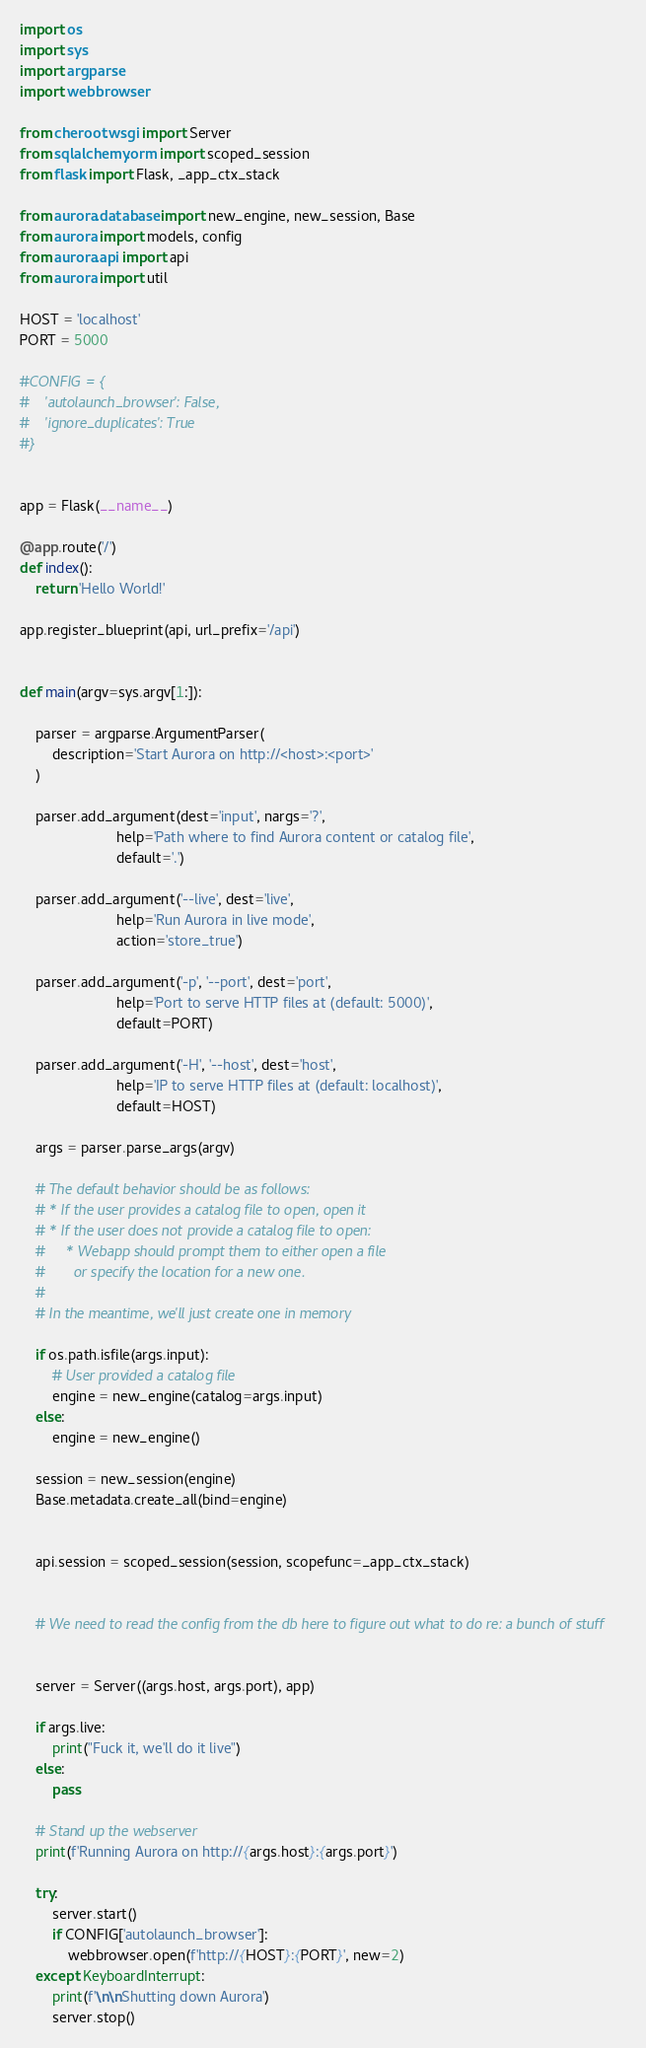Convert code to text. <code><loc_0><loc_0><loc_500><loc_500><_Python_>import os
import sys
import argparse
import webbrowser

from cheroot.wsgi import Server
from sqlalchemy.orm import scoped_session
from flask import Flask, _app_ctx_stack

from aurora.database import new_engine, new_session, Base
from aurora import models, config
from aurora.api import api
from aurora import util

HOST = 'localhost'
PORT = 5000

#CONFIG = {
#    'autolaunch_browser': False,
#    'ignore_duplicates': True
#}


app = Flask(__name__)

@app.route('/')
def index():
    return 'Hello World!'

app.register_blueprint(api, url_prefix='/api')


def main(argv=sys.argv[1:]):

    parser = argparse.ArgumentParser(
        description='Start Aurora on http://<host>:<port>'
    )
    
    parser.add_argument(dest='input', nargs='?',
                        help='Path where to find Aurora content or catalog file',
                        default='.')

    parser.add_argument('--live', dest='live',
                        help='Run Aurora in live mode',
                        action='store_true')

    parser.add_argument('-p', '--port', dest='port',
                        help='Port to serve HTTP files at (default: 5000)',
                        default=PORT)

    parser.add_argument('-H', '--host', dest='host',
                        help='IP to serve HTTP files at (default: localhost)',
                        default=HOST)
    
    args = parser.parse_args(argv)

    # The default behavior should be as follows:
    # * If the user provides a catalog file to open, open it
    # * If the user does not provide a catalog file to open:
    #     * Webapp should prompt them to either open a file
    #       or specify the location for a new one.
    #
    # In the meantime, we'll just create one in memory

    if os.path.isfile(args.input):
        # User provided a catalog file
        engine = new_engine(catalog=args.input)
    else:
        engine = new_engine()

    session = new_session(engine)
    Base.metadata.create_all(bind=engine)


    api.session = scoped_session(session, scopefunc=_app_ctx_stack)


    # We need to read the config from the db here to figure out what to do re: a bunch of stuff


    server = Server((args.host, args.port), app)

    if args.live:
        print("Fuck it, we'll do it live")
    else:
        pass

    # Stand up the webserver
    print(f'Running Aurora on http://{args.host}:{args.port}')

    try:
        server.start()
        if CONFIG['autolaunch_browser']:
            webbrowser.open(f'http://{HOST}:{PORT}', new=2)
    except KeyboardInterrupt:
        print(f'\n\nShutting down Aurora')
        server.stop()

</code> 